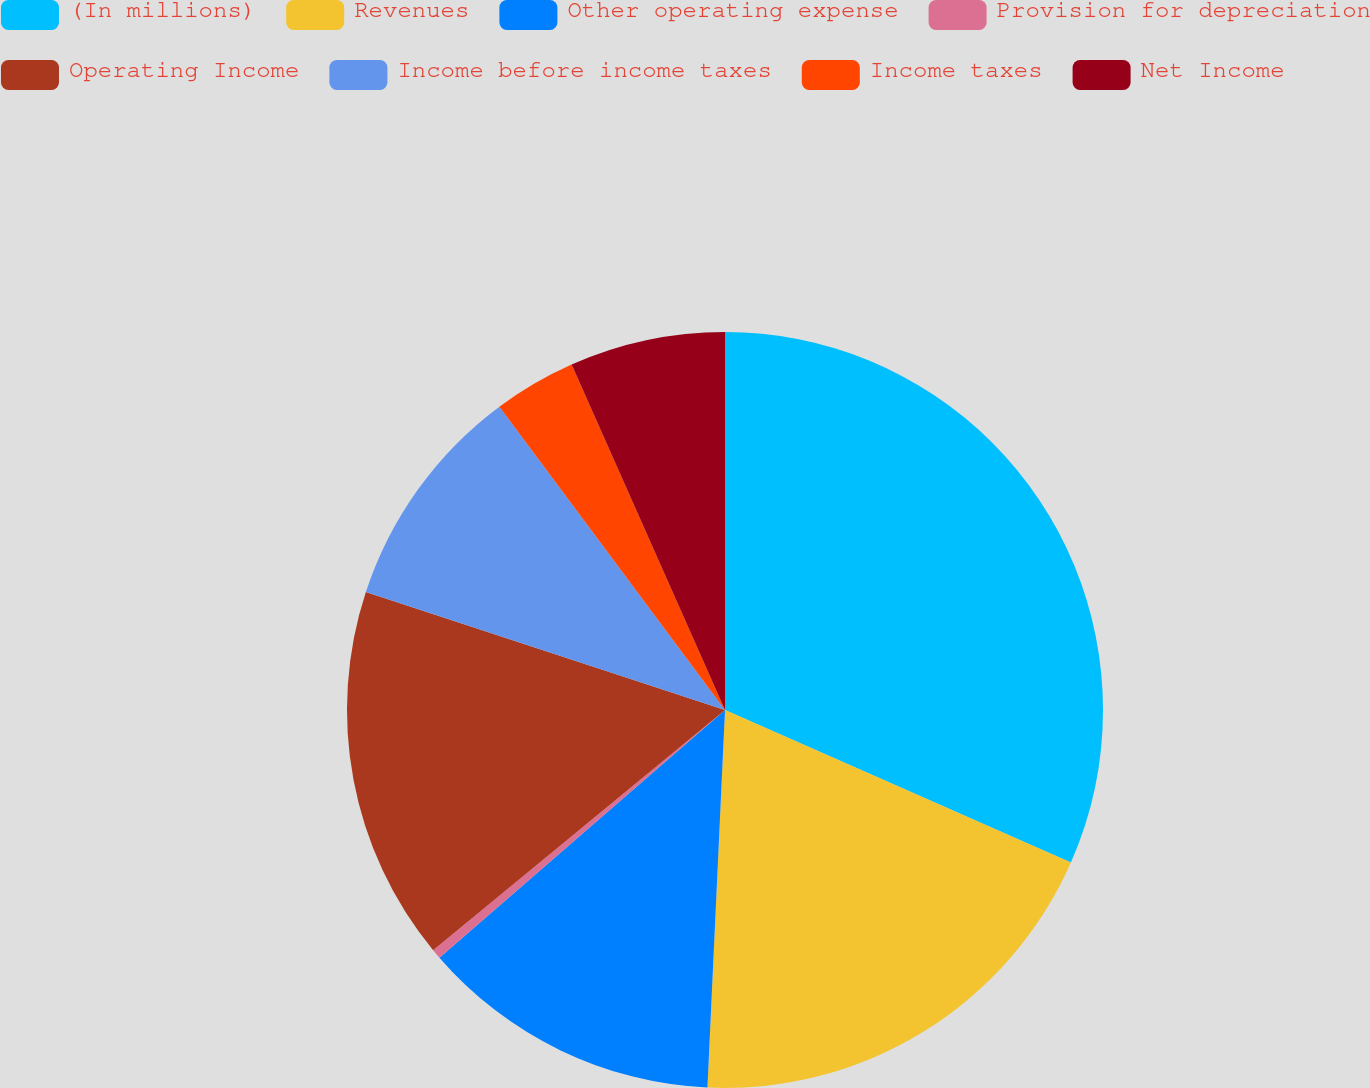Convert chart to OTSL. <chart><loc_0><loc_0><loc_500><loc_500><pie_chart><fcel>(In millions)<fcel>Revenues<fcel>Other operating expense<fcel>Provision for depreciation<fcel>Operating Income<fcel>Income before income taxes<fcel>Income taxes<fcel>Net Income<nl><fcel>31.61%<fcel>19.13%<fcel>12.89%<fcel>0.41%<fcel>16.01%<fcel>9.77%<fcel>3.53%<fcel>6.65%<nl></chart> 